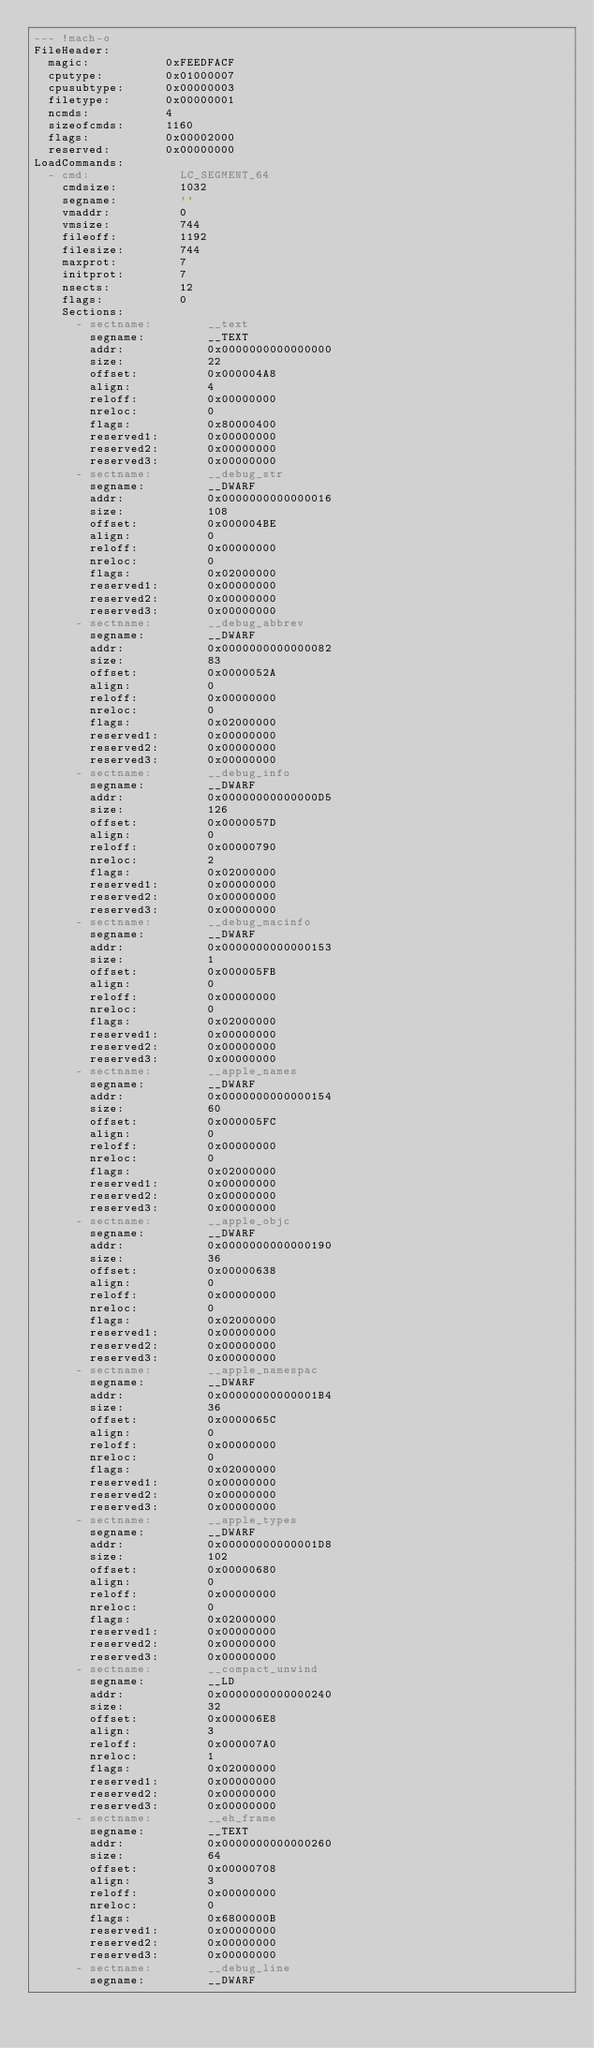<code> <loc_0><loc_0><loc_500><loc_500><_YAML_>--- !mach-o
FileHeader:      
  magic:           0xFEEDFACF
  cputype:         0x01000007
  cpusubtype:      0x00000003
  filetype:        0x00000001
  ncmds:           4
  sizeofcmds:      1160
  flags:           0x00002000
  reserved:        0x00000000
LoadCommands:    
  - cmd:             LC_SEGMENT_64
    cmdsize:         1032
    segname:         ''
    vmaddr:          0
    vmsize:          744
    fileoff:         1192
    filesize:        744
    maxprot:         7
    initprot:        7
    nsects:          12
    flags:           0
    Sections:        
      - sectname:        __text
        segname:         __TEXT
        addr:            0x0000000000000000
        size:            22
        offset:          0x000004A8
        align:           4
        reloff:          0x00000000
        nreloc:          0
        flags:           0x80000400
        reserved1:       0x00000000
        reserved2:       0x00000000
        reserved3:       0x00000000
      - sectname:        __debug_str
        segname:         __DWARF
        addr:            0x0000000000000016
        size:            108
        offset:          0x000004BE
        align:           0
        reloff:          0x00000000
        nreloc:          0
        flags:           0x02000000
        reserved1:       0x00000000
        reserved2:       0x00000000
        reserved3:       0x00000000
      - sectname:        __debug_abbrev
        segname:         __DWARF
        addr:            0x0000000000000082
        size:            83
        offset:          0x0000052A
        align:           0
        reloff:          0x00000000
        nreloc:          0
        flags:           0x02000000
        reserved1:       0x00000000
        reserved2:       0x00000000
        reserved3:       0x00000000
      - sectname:        __debug_info
        segname:         __DWARF
        addr:            0x00000000000000D5
        size:            126
        offset:          0x0000057D
        align:           0
        reloff:          0x00000790
        nreloc:          2
        flags:           0x02000000
        reserved1:       0x00000000
        reserved2:       0x00000000
        reserved3:       0x00000000
      - sectname:        __debug_macinfo
        segname:         __DWARF
        addr:            0x0000000000000153
        size:            1
        offset:          0x000005FB
        align:           0
        reloff:          0x00000000
        nreloc:          0
        flags:           0x02000000
        reserved1:       0x00000000
        reserved2:       0x00000000
        reserved3:       0x00000000
      - sectname:        __apple_names
        segname:         __DWARF
        addr:            0x0000000000000154
        size:            60
        offset:          0x000005FC
        align:           0
        reloff:          0x00000000
        nreloc:          0
        flags:           0x02000000
        reserved1:       0x00000000
        reserved2:       0x00000000
        reserved3:       0x00000000
      - sectname:        __apple_objc
        segname:         __DWARF
        addr:            0x0000000000000190
        size:            36
        offset:          0x00000638
        align:           0
        reloff:          0x00000000
        nreloc:          0
        flags:           0x02000000
        reserved1:       0x00000000
        reserved2:       0x00000000
        reserved3:       0x00000000
      - sectname:        __apple_namespac
        segname:         __DWARF
        addr:            0x00000000000001B4
        size:            36
        offset:          0x0000065C
        align:           0
        reloff:          0x00000000
        nreloc:          0
        flags:           0x02000000
        reserved1:       0x00000000
        reserved2:       0x00000000
        reserved3:       0x00000000
      - sectname:        __apple_types
        segname:         __DWARF
        addr:            0x00000000000001D8
        size:            102
        offset:          0x00000680
        align:           0
        reloff:          0x00000000
        nreloc:          0
        flags:           0x02000000
        reserved1:       0x00000000
        reserved2:       0x00000000
        reserved3:       0x00000000
      - sectname:        __compact_unwind
        segname:         __LD
        addr:            0x0000000000000240
        size:            32
        offset:          0x000006E8
        align:           3
        reloff:          0x000007A0
        nreloc:          1
        flags:           0x02000000
        reserved1:       0x00000000
        reserved2:       0x00000000
        reserved3:       0x00000000
      - sectname:        __eh_frame
        segname:         __TEXT
        addr:            0x0000000000000260
        size:            64
        offset:          0x00000708
        align:           3
        reloff:          0x00000000
        nreloc:          0
        flags:           0x6800000B
        reserved1:       0x00000000
        reserved2:       0x00000000
        reserved3:       0x00000000
      - sectname:        __debug_line
        segname:         __DWARF</code> 